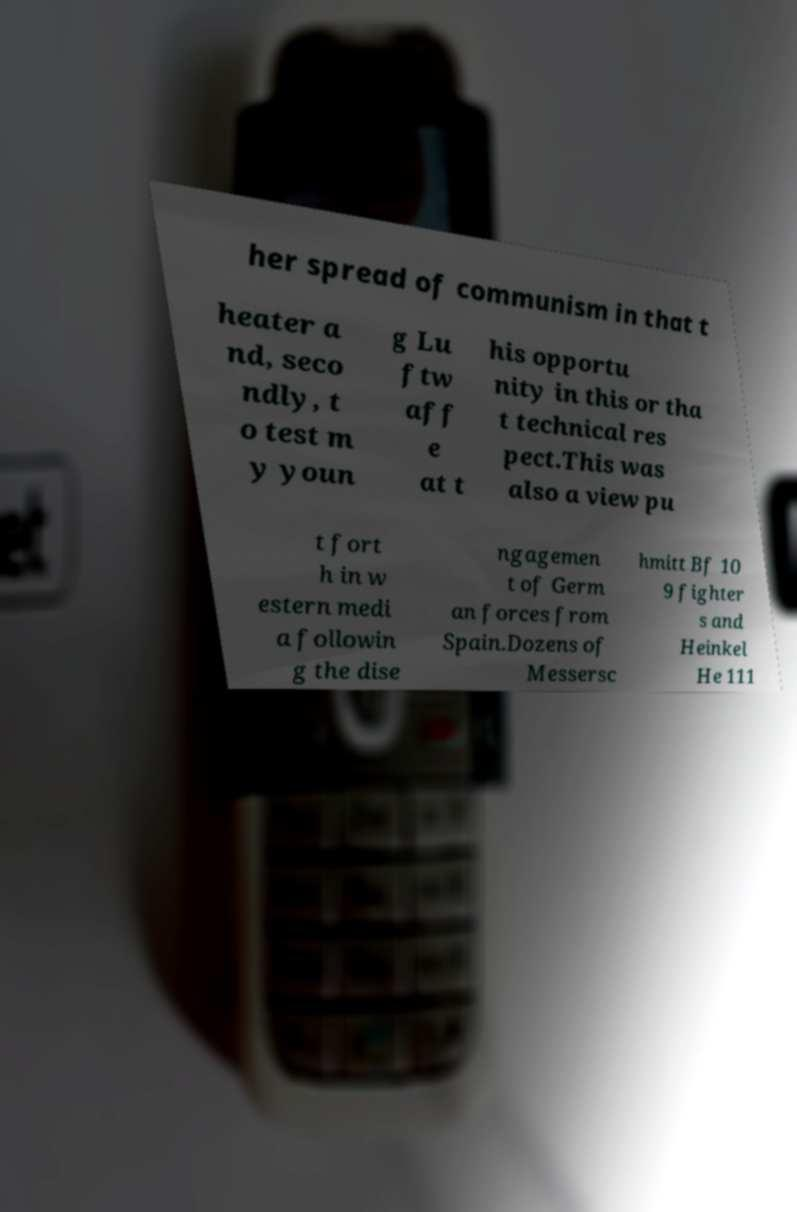Please identify and transcribe the text found in this image. her spread of communism in that t heater a nd, seco ndly, t o test m y youn g Lu ftw aff e at t his opportu nity in this or tha t technical res pect.This was also a view pu t fort h in w estern medi a followin g the dise ngagemen t of Germ an forces from Spain.Dozens of Messersc hmitt Bf 10 9 fighter s and Heinkel He 111 